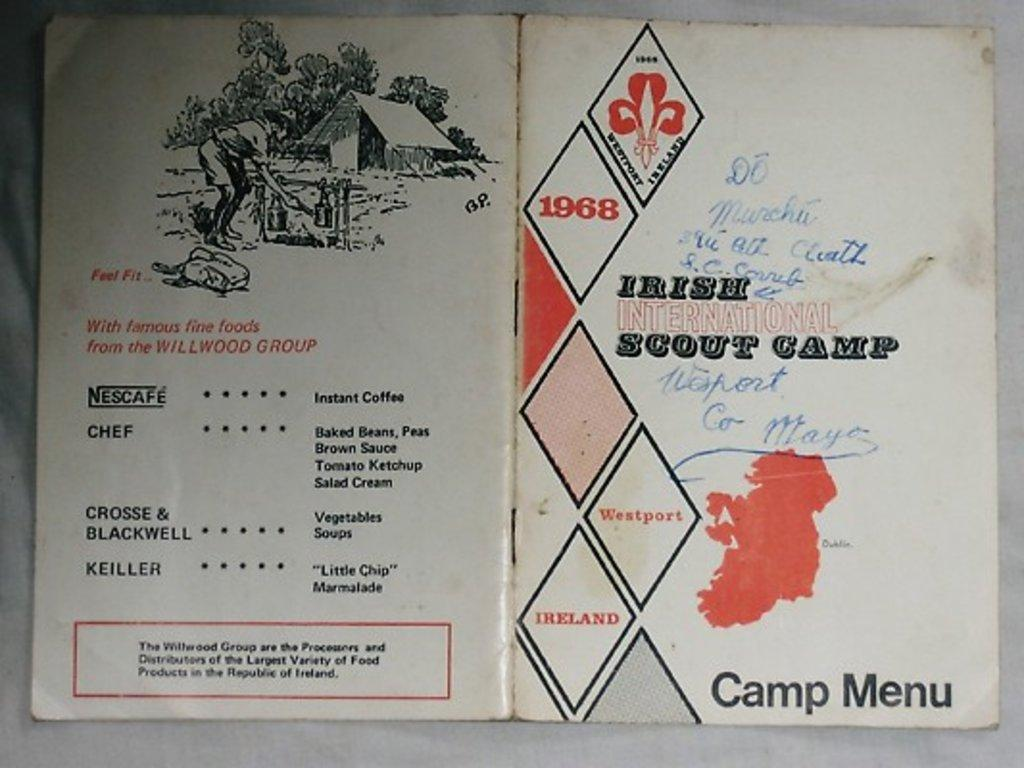<image>
Render a clear and concise summary of the photo. A booklet from 1968 contains the camp menu from Irish International Scout Camp. 